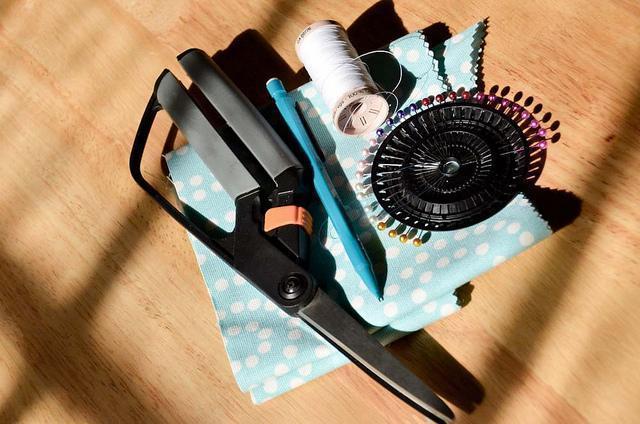How many people in the front row are smiling?
Give a very brief answer. 0. 